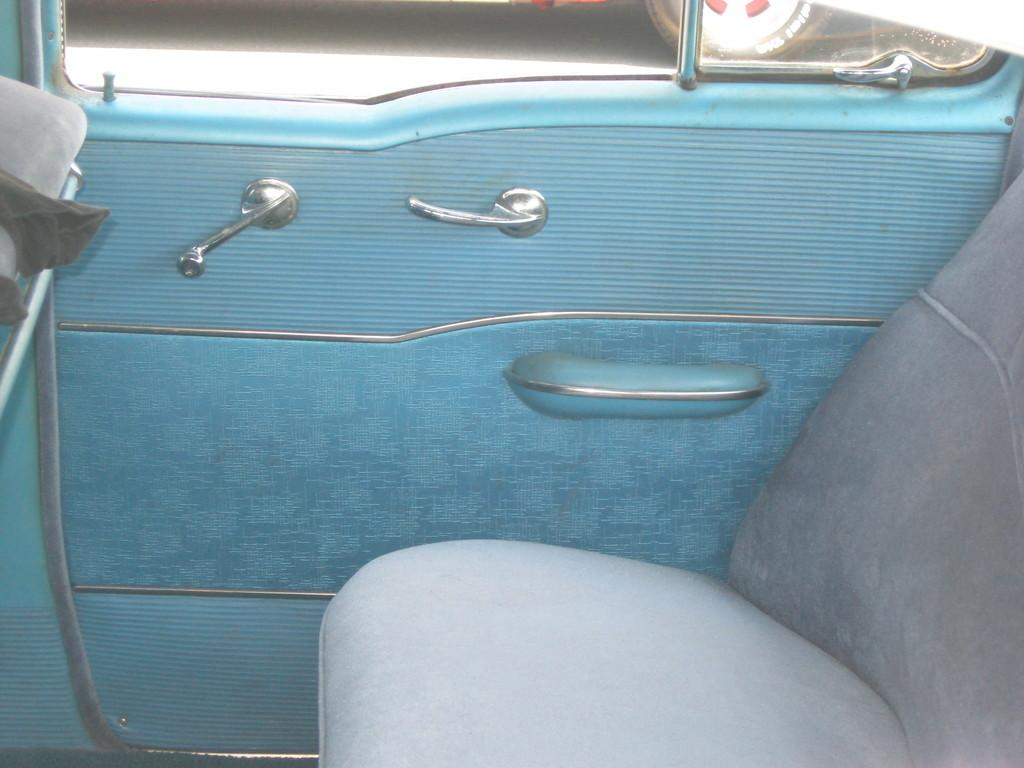What type of setting is depicted in the image? The image shows an inside view of a car. What can be found inside the car? There is a seat in the car. Are there any features that allow passengers to enter or exit the car? Yes, there are handles to the door in the car. What can be seen in the background of the image? The wheel of a vehicle is visible in the background on the road. What type of sock is hanging from the rearview mirror in the image? There is no sock present in the image; it only depicts the inside of a car with a seat, door handles, and a wheel in the background. 